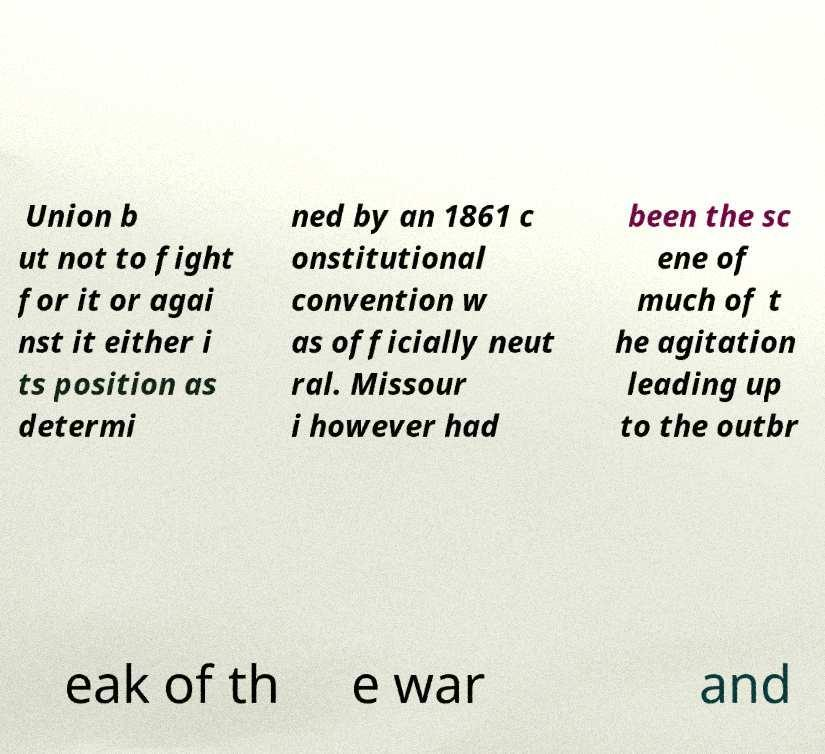Can you accurately transcribe the text from the provided image for me? Union b ut not to fight for it or agai nst it either i ts position as determi ned by an 1861 c onstitutional convention w as officially neut ral. Missour i however had been the sc ene of much of t he agitation leading up to the outbr eak of th e war and 